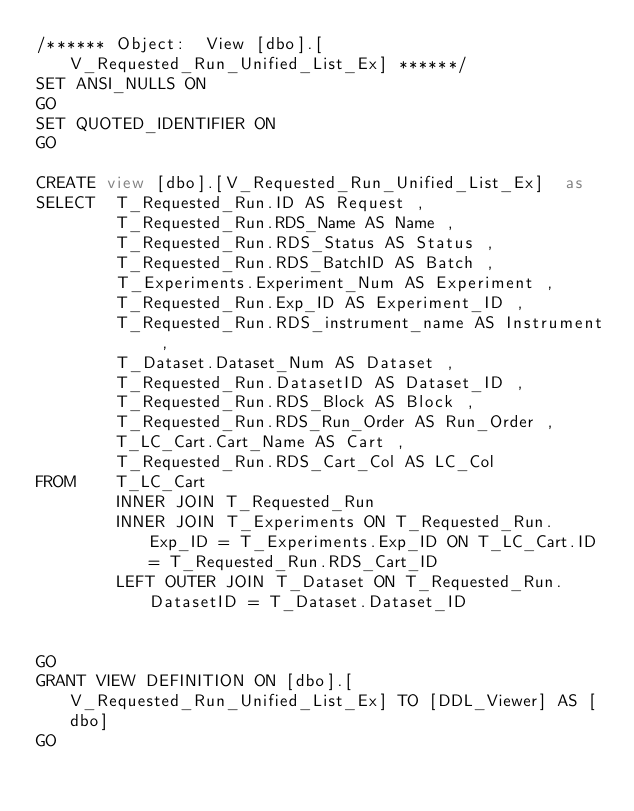<code> <loc_0><loc_0><loc_500><loc_500><_SQL_>/****** Object:  View [dbo].[V_Requested_Run_Unified_List_Ex] ******/
SET ANSI_NULLS ON
GO
SET QUOTED_IDENTIFIER ON
GO

CREATE view [dbo].[V_Requested_Run_Unified_List_Ex]  as
SELECT  T_Requested_Run.ID AS Request ,
        T_Requested_Run.RDS_Name AS Name ,
        T_Requested_Run.RDS_Status AS Status ,
        T_Requested_Run.RDS_BatchID AS Batch ,
        T_Experiments.Experiment_Num AS Experiment ,
        T_Requested_Run.Exp_ID AS Experiment_ID ,
        T_Requested_Run.RDS_instrument_name AS Instrument ,
        T_Dataset.Dataset_Num AS Dataset ,
        T_Requested_Run.DatasetID AS Dataset_ID ,
        T_Requested_Run.RDS_Block AS Block ,
        T_Requested_Run.RDS_Run_Order AS Run_Order ,
        T_LC_Cart.Cart_Name AS Cart ,
        T_Requested_Run.RDS_Cart_Col AS LC_Col
FROM    T_LC_Cart
        INNER JOIN T_Requested_Run
        INNER JOIN T_Experiments ON T_Requested_Run.Exp_ID = T_Experiments.Exp_ID ON T_LC_Cart.ID = T_Requested_Run.RDS_Cart_ID
        LEFT OUTER JOIN T_Dataset ON T_Requested_Run.DatasetID = T_Dataset.Dataset_ID


GO
GRANT VIEW DEFINITION ON [dbo].[V_Requested_Run_Unified_List_Ex] TO [DDL_Viewer] AS [dbo]
GO
</code> 